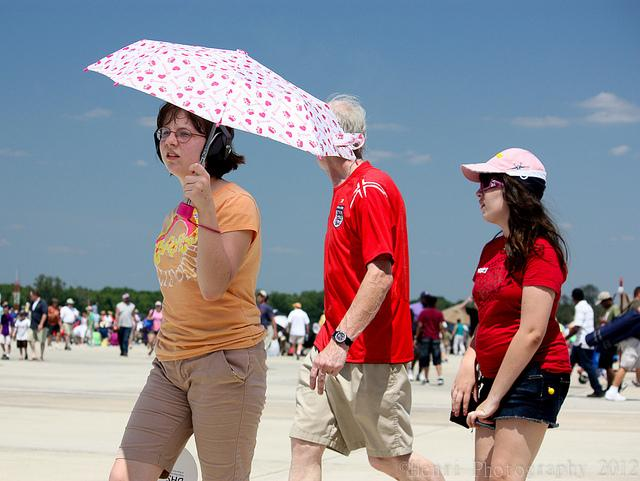The person holding the umbrella looks most like who? Please explain your reasoning. amber tamblyn. Based on the person holding the umbrella and a google search of the answers provided, a is closest in features and general appearance. 